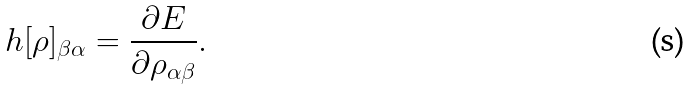Convert formula to latex. <formula><loc_0><loc_0><loc_500><loc_500>h [ \rho ] _ { \beta \alpha } = \frac { \partial E } { \partial \rho _ { \alpha \beta } } .</formula> 